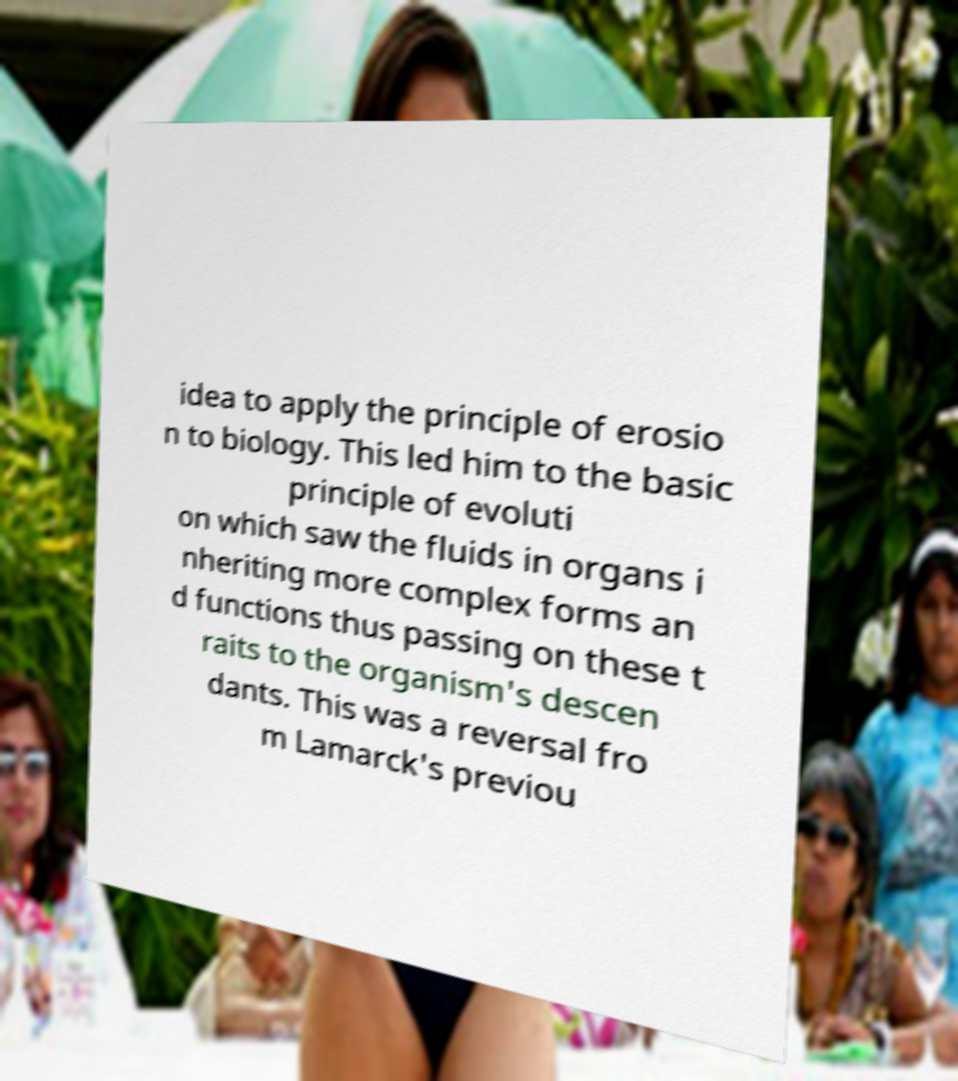There's text embedded in this image that I need extracted. Can you transcribe it verbatim? idea to apply the principle of erosio n to biology. This led him to the basic principle of evoluti on which saw the fluids in organs i nheriting more complex forms an d functions thus passing on these t raits to the organism's descen dants. This was a reversal fro m Lamarck's previou 